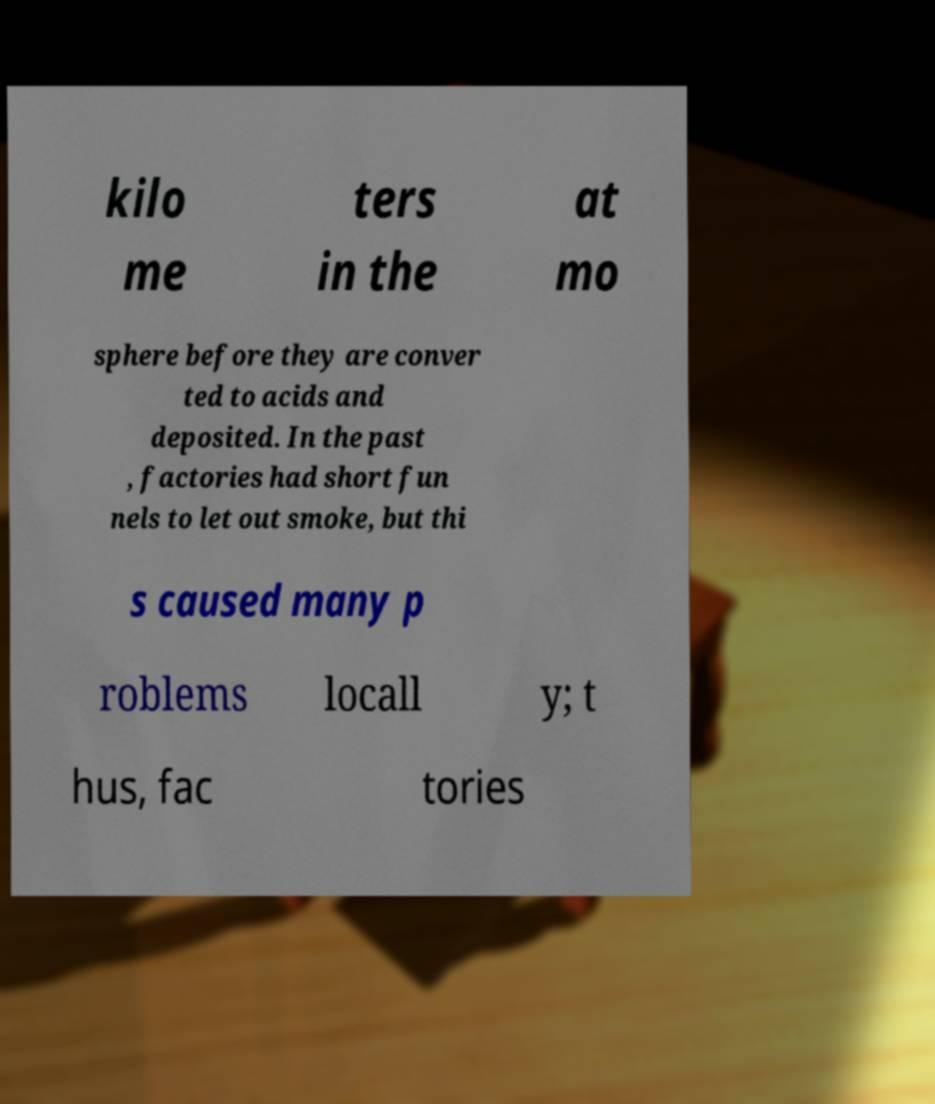Could you assist in decoding the text presented in this image and type it out clearly? kilo me ters in the at mo sphere before they are conver ted to acids and deposited. In the past , factories had short fun nels to let out smoke, but thi s caused many p roblems locall y; t hus, fac tories 